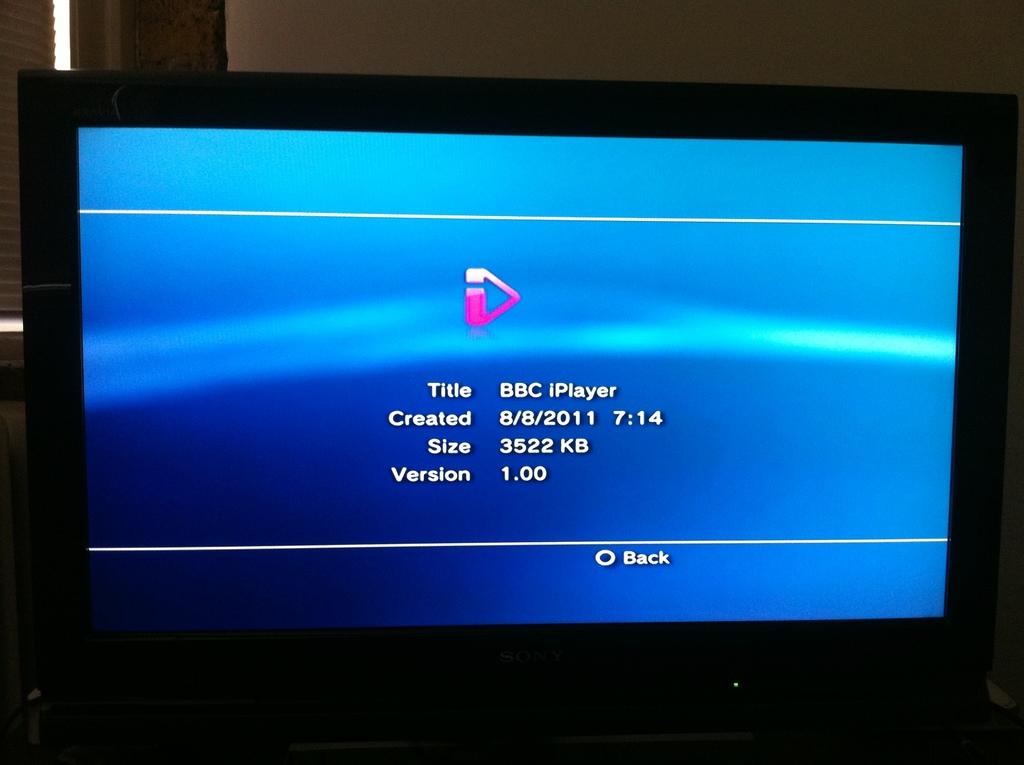What application is running?
Make the answer very short. Bbc iplayer. What does the text say by the circle?
Make the answer very short. Back. 